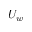Convert formula to latex. <formula><loc_0><loc_0><loc_500><loc_500>U _ { w }</formula> 